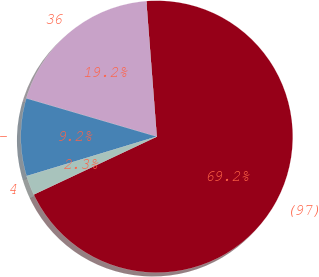<chart> <loc_0><loc_0><loc_500><loc_500><pie_chart><fcel>(97)<fcel>36<fcel>-<fcel>4<nl><fcel>69.23%<fcel>19.23%<fcel>9.23%<fcel>2.31%<nl></chart> 